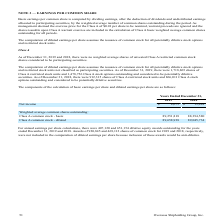According to Overseas Shipholding Group's financial document, Was there weighted average shares of unvested Class A restricted common stock shares considered to be participating securities as of December 31, 2019 and 2018? As of December 31, 2019 and 2018, there were no weighted average shares of unvested Class A restricted common stock shares considered to be participating securities.. The document states: "As of December 31, 2019 and 2018, there were no weighted average shares of unvested Class A restricted common stock shares considered to be participat..." Also, How much was the shares of Class A restricted stock unit as of December 31, 2019? According to the financial document, 1,718,865. The relevant text states: "g securities. As of December 31, 2019, there were 1,718,865 shares of Class A restricted stock units and 1,478,756 Class A stock options outstanding and consid..." Also, How much was the shares of Class A restricted stock unit as of December 31, 2018? According to the financial document, 912,315. The relevant text states: "e securities. As of December 31, 2018, there were 912,315 shares of Class A restricted stock units and 866,011 Class A stock options outstanding and consider..." Also, can you calculate: What is the change in Net income from Years Ended December 31, 2018 to 2019? Based on the calculation: 8,675-13,489, the result is -4814. This is based on the information: "Net income $ 8,675 $ 13,489 Net income $ 8,675 $ 13,489..." The key data points involved are: 13,489, 8,675. Also, can you calculate: What is the change in Weighted average common shares outstanding: Class A common stock – basic from Years Ended December 31, 2018 to 2019? Based on the calculation: 89,251,818-88,394,580, the result is 857238. This is based on the information: "standing: Class A common stock - basic 89,251,818 88,394,580 shares outstanding: Class A common stock - basic 89,251,818 88,394,580..." The key data points involved are: 88,394,580, 89,251,818. Also, can you calculate: What is the average Net income for Years Ended December 31, 2018 to 2019? To answer this question, I need to perform calculations using the financial data. The calculation is: (8,675+13,489) / 2, which equals 11082. This is based on the information: "Net income $ 8,675 $ 13,489 Net income $ 8,675 $ 13,489..." The key data points involved are: 13,489, 8,675. 